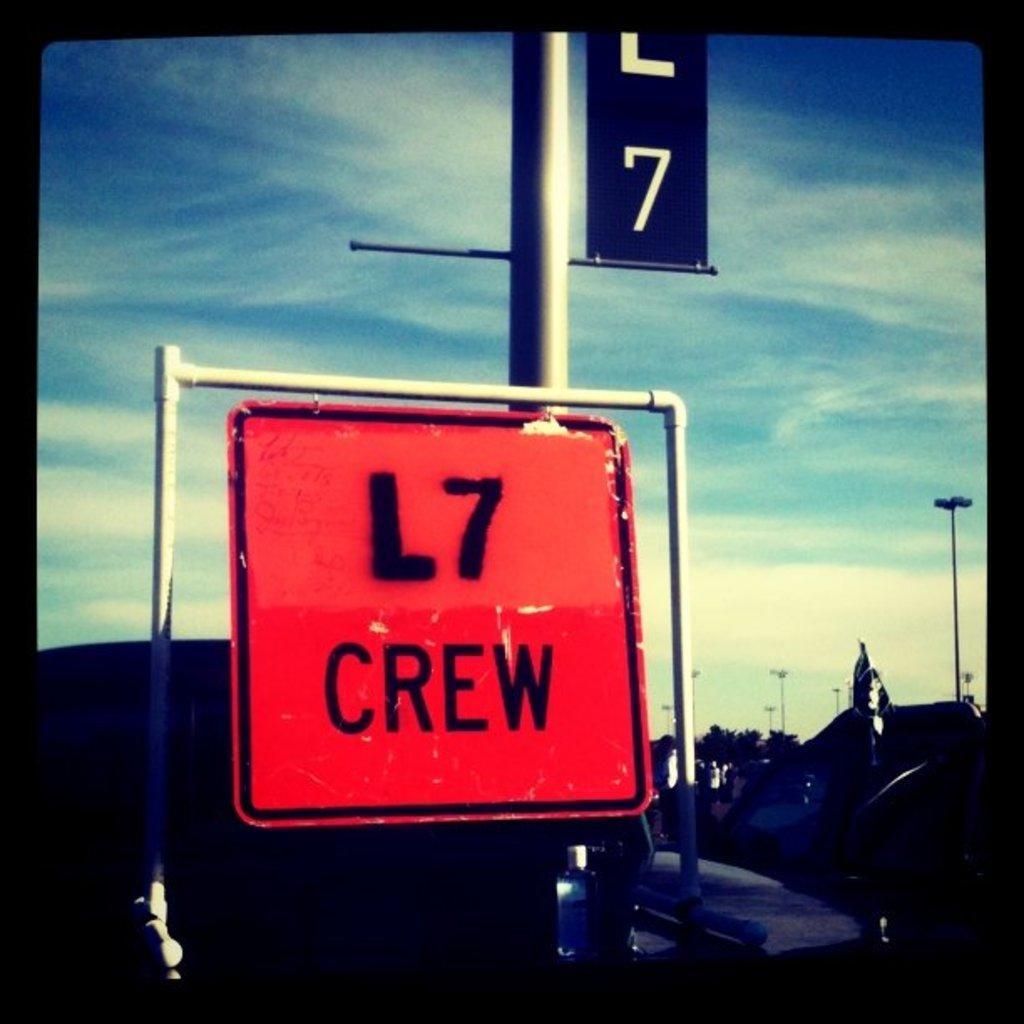What army is this?
Your response must be concise. Unanswerable. What is the crew name?
Ensure brevity in your answer.  L7. 